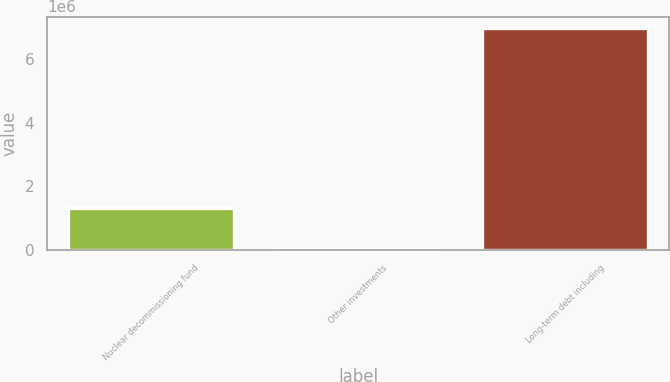<chart> <loc_0><loc_0><loc_500><loc_500><bar_chart><fcel>Nuclear decommissioning fund<fcel>Other investments<fcel>Long-term debt including<nl><fcel>1.31756e+06<fcel>40019<fcel>6.9797e+06<nl></chart> 